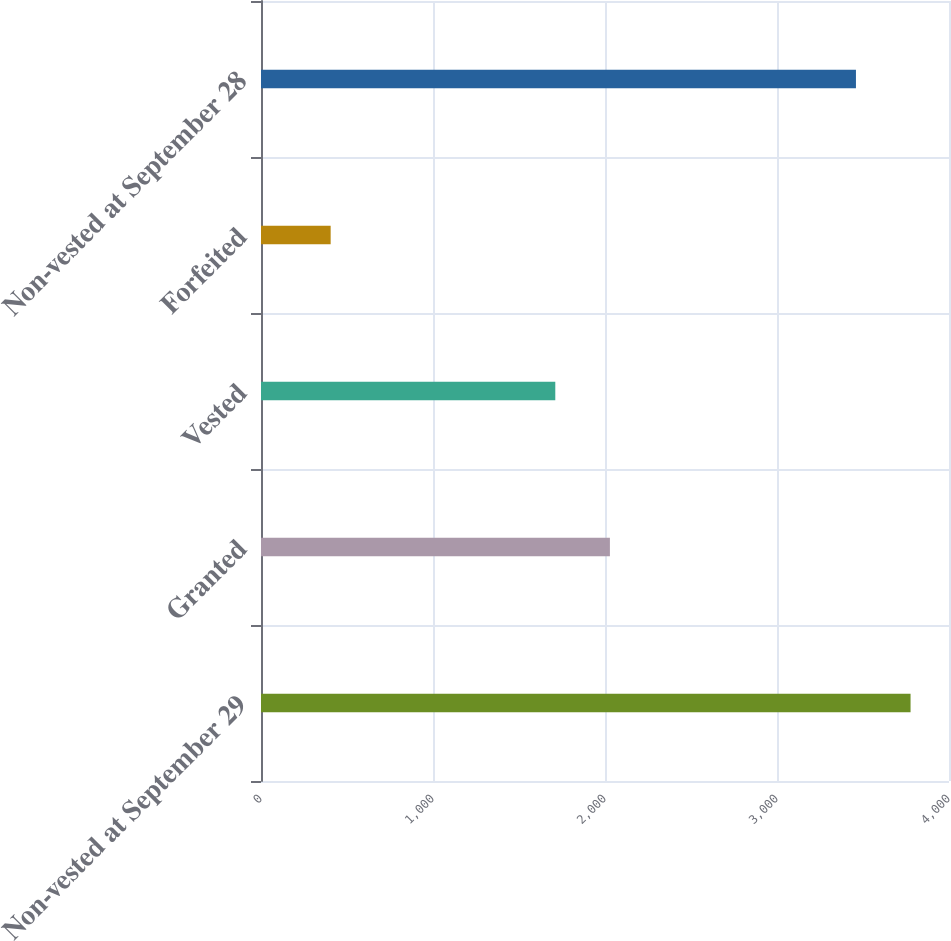<chart> <loc_0><loc_0><loc_500><loc_500><bar_chart><fcel>Non-vested at September 29<fcel>Granted<fcel>Vested<fcel>Forfeited<fcel>Non-vested at September 28<nl><fcel>3776.5<fcel>2028.5<fcel>1711<fcel>405<fcel>3459<nl></chart> 